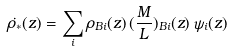<formula> <loc_0><loc_0><loc_500><loc_500>\dot { \rho _ { * } } ( z ) = \sum _ { i } \rho _ { B i } ( z ) \, ( \frac { M } { L } ) _ { B i } ( z ) \, \psi _ { i } ( z )</formula> 